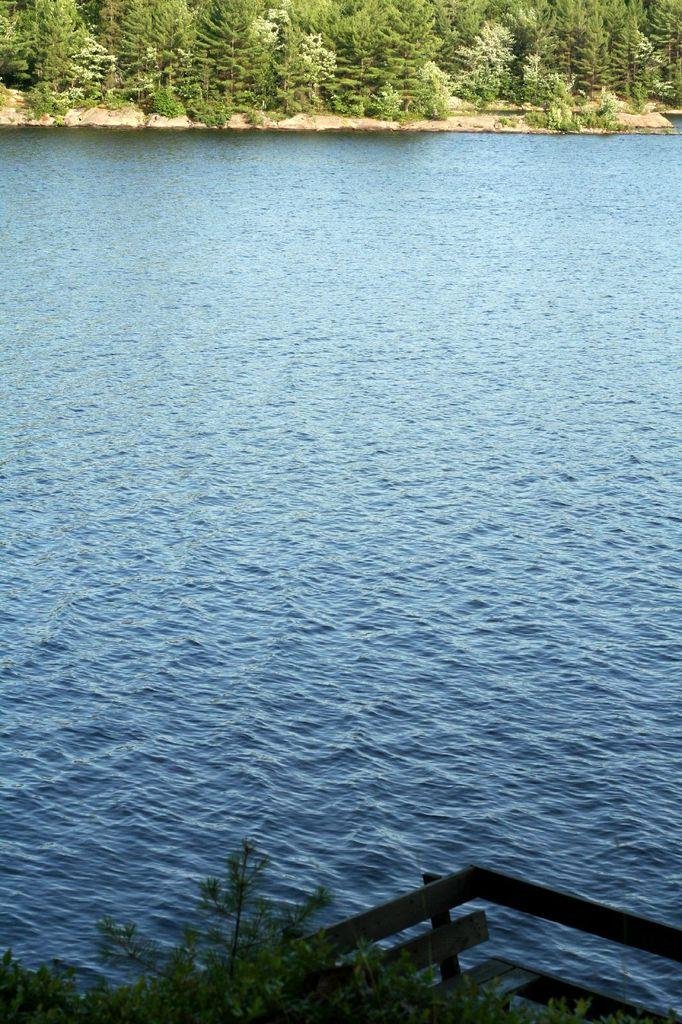What is located in the middle of the image? There is a water surface in the middle of the image. What can be seen in the background of the image? There are groups of trees in the background of the image. What type of statement can be seen written on the water surface in the image? There is no statement visible on the water surface in the image. Can you spot an owl perched on one of the trees in the image? There is no owl present in the image. Is there any indication of a fight or conflict happening in the image? There is no indication of a fight or conflict in the image. 